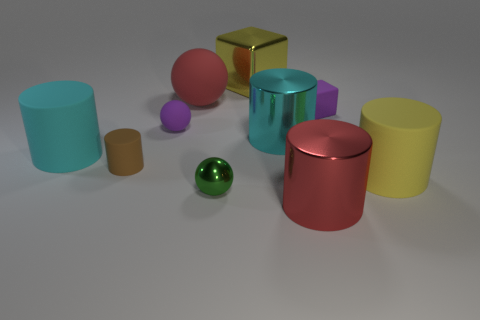The cyan cylinder to the right of the red thing left of the cyan cylinder that is right of the big metallic block is made of what material?
Make the answer very short. Metal. What color is the big rubber cylinder on the left side of the big rubber cylinder that is in front of the brown rubber cylinder?
Your response must be concise. Cyan. How many large things are either rubber things or yellow matte cylinders?
Ensure brevity in your answer.  3. How many yellow blocks are made of the same material as the red sphere?
Your answer should be very brief. 0. How big is the red object that is in front of the small purple cube?
Offer a terse response. Large. There is a small purple object that is to the left of the big cylinder that is in front of the yellow matte cylinder; what is its shape?
Provide a succinct answer. Sphere. There is a large matte cylinder that is in front of the big cylinder to the left of the small shiny sphere; how many blocks are right of it?
Offer a very short reply. 0. Is the number of small objects that are behind the tiny purple matte sphere less than the number of purple cubes?
Ensure brevity in your answer.  No. Is there anything else that has the same shape as the tiny green thing?
Your answer should be very brief. Yes. There is a small purple matte thing to the left of the tiny green ball; what shape is it?
Provide a short and direct response. Sphere. 